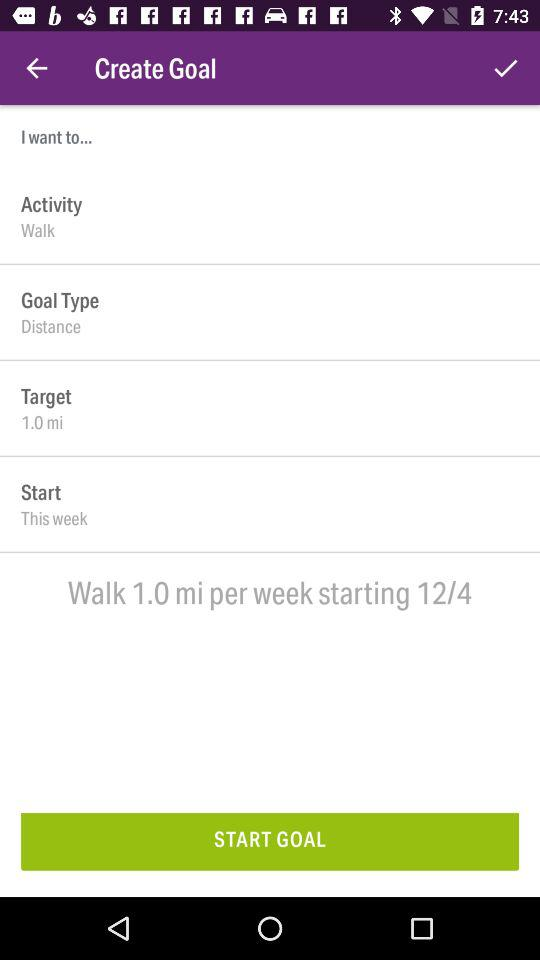What option is selected in "Goal Type"? The selected option is "Distance". 